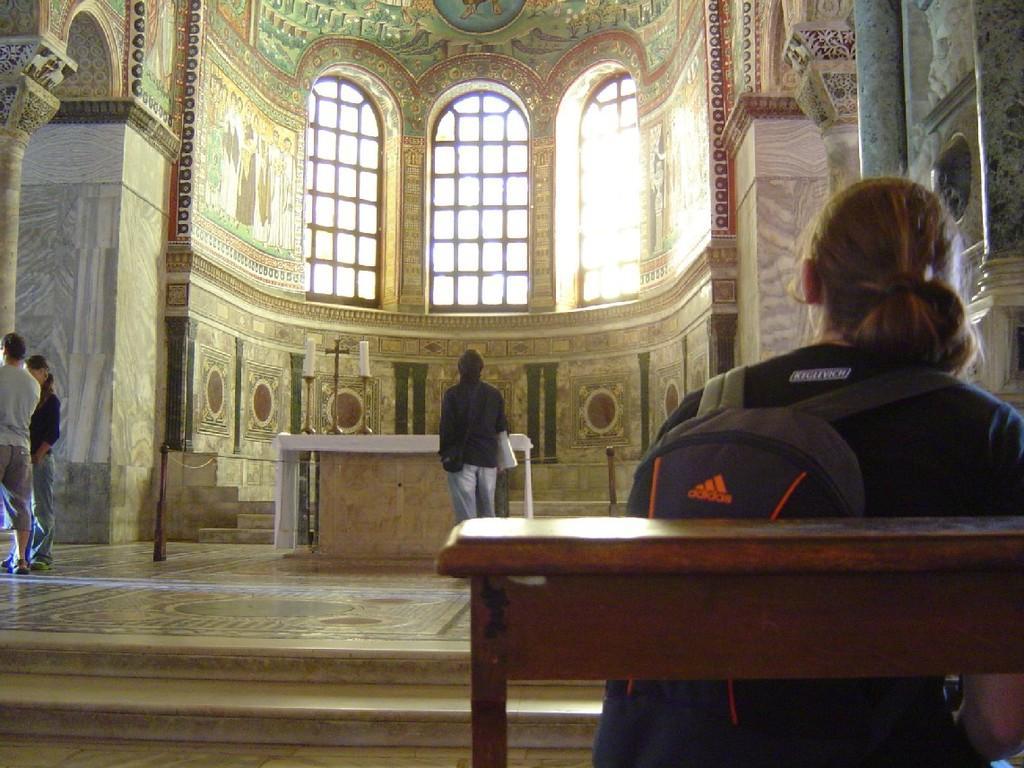Please provide a concise description of this image. In this image we can see windows, walls, candles, stairs, people and some other objects. 